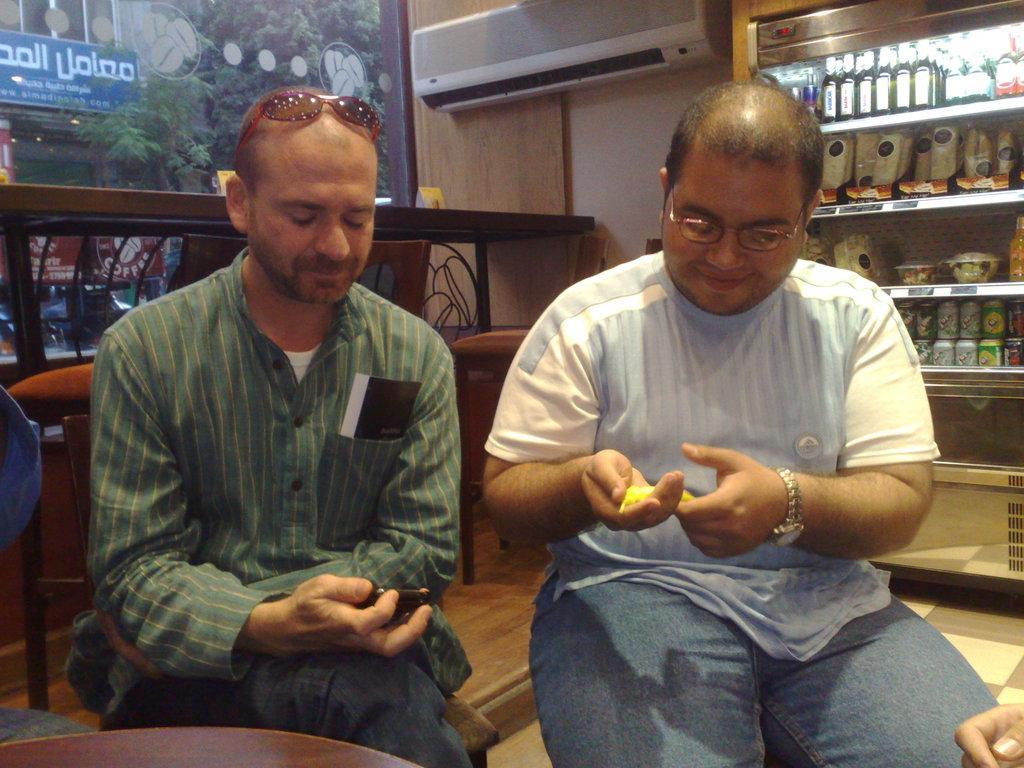Could you give a brief overview of what you see in this image? In this image, we can see people sitting and one of them is holding an object and wearing glasses and the other is having a paper in his pocket. In the background, there is a board, an ac and we can see some bottles, bowls, jars in the shelves and we can see some chairs, tables and a wall. At the bottom, there is floor. 